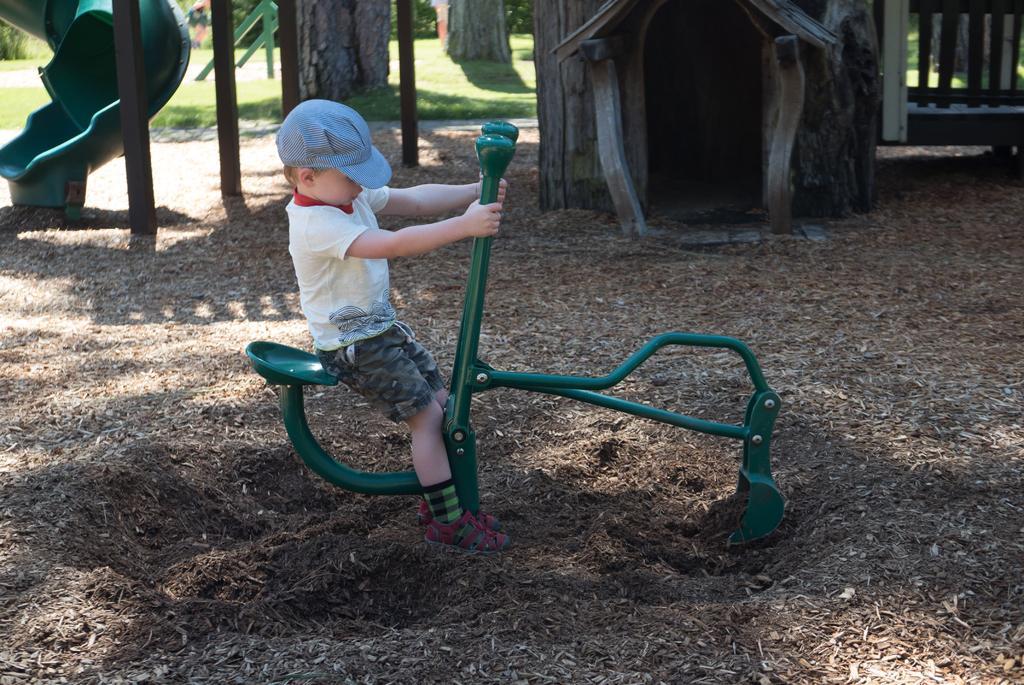Can you describe this image briefly? In this image I can see a person sitting on the green color object I can see tree-house,mud,trees and some-objects. 